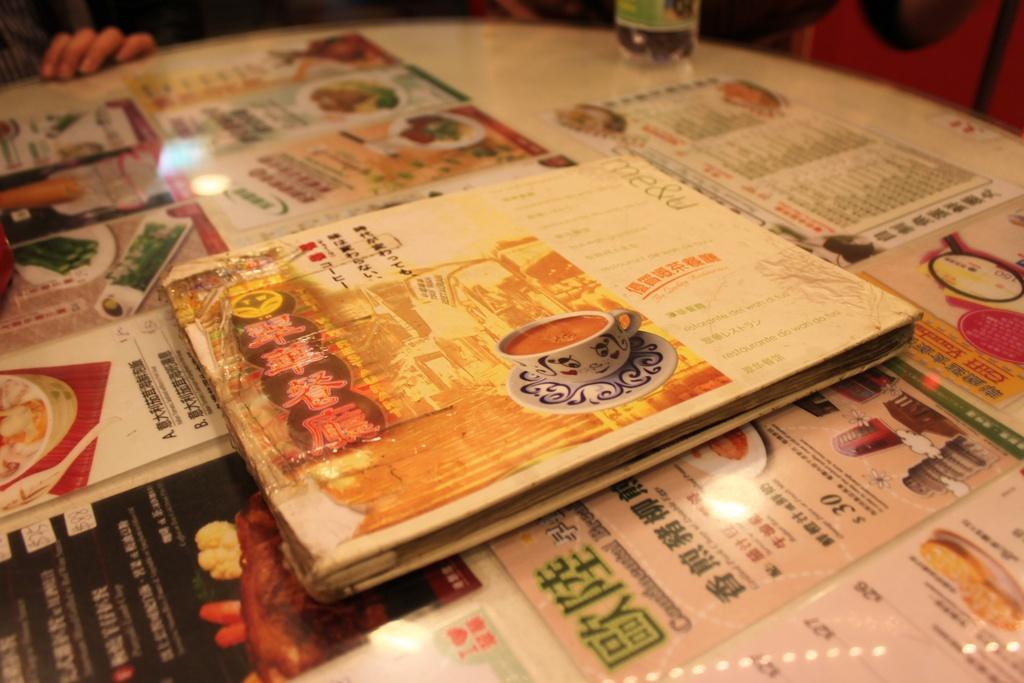<image>
Give a short and clear explanation of the subsequent image. Several Chinese menus sit on a table with one dish costing $30 